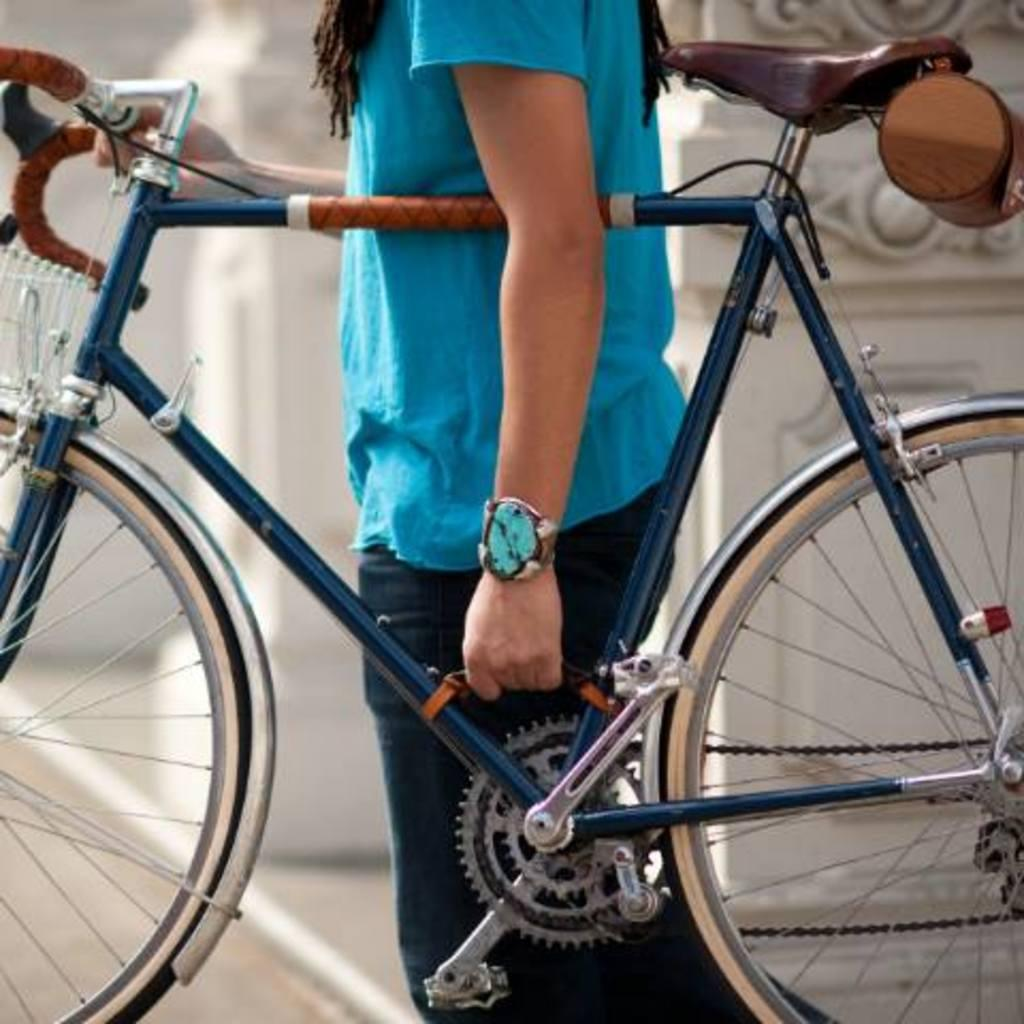What is the main subject of the image? There is a person in the image. What is the person holding in the image? The person is holding a bicycle. Can you describe the background of the image? The background of the image is blurred. What type of hill can be seen in the background of the image? There is no hill visible in the image; the background is blurred. 